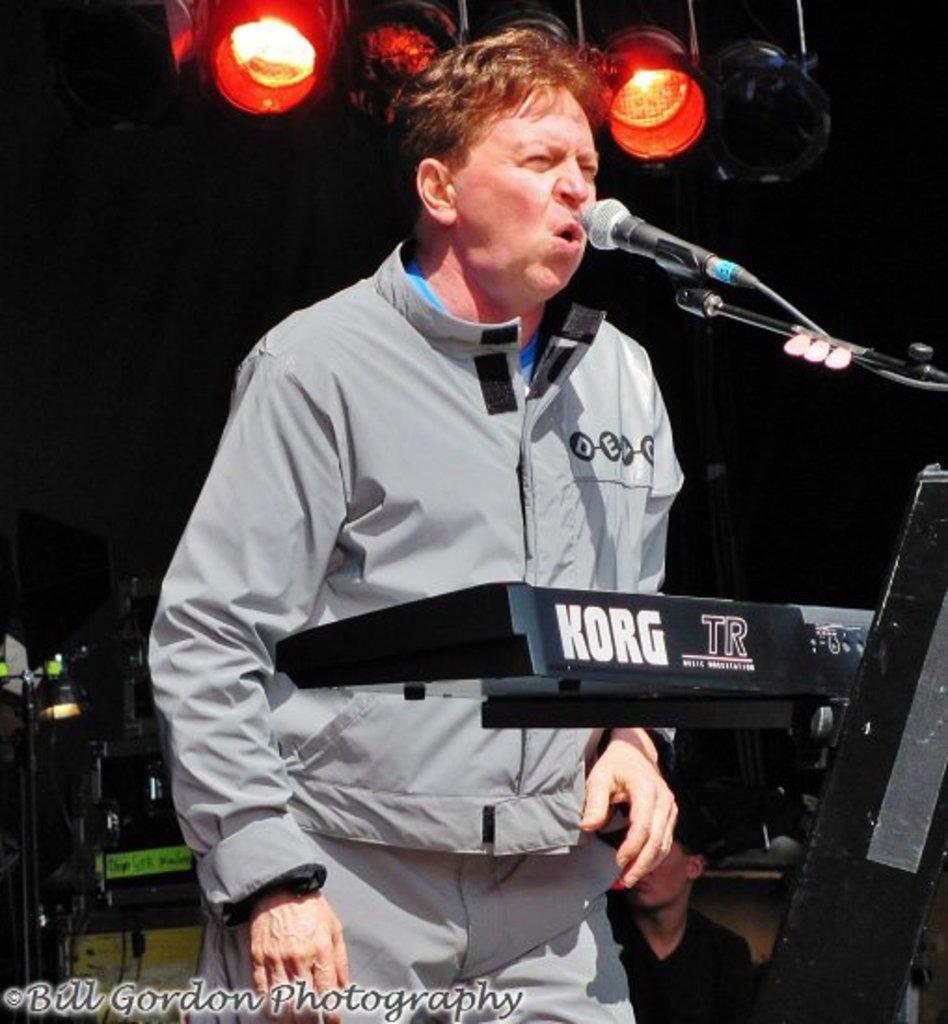Please provide a concise description of this image. In this image I see a man and I see the tripod on which there is a mic and I see alphabets written over here and I see that it is dark in the background and I see the lights over here. 